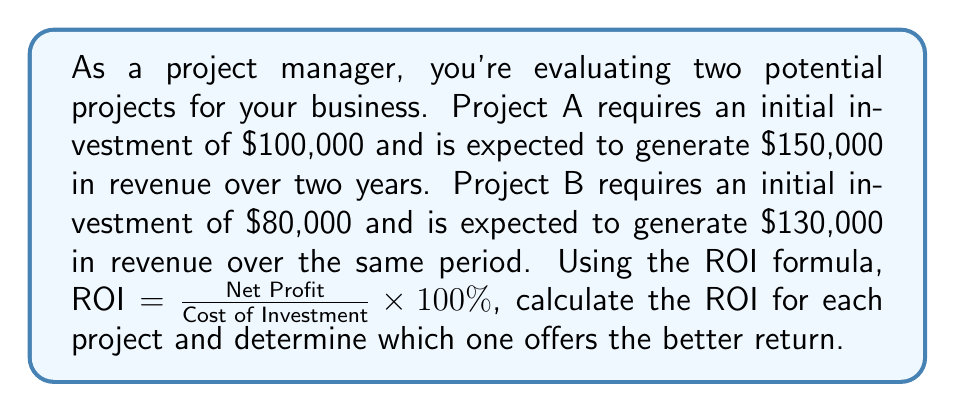Teach me how to tackle this problem. Let's calculate the ROI for each project:

1. Project A:
   - Initial Investment: $100,000
   - Revenue: $150,000
   - Net Profit = Revenue - Initial Investment
   $$Net Profit_A = 150,000 - 100,000 = 50,000$$
   
   ROI for Project A:
   $$ROI_A = \frac{50,000}{100,000} \times 100\% = 50\%$$

2. Project B:
   - Initial Investment: $80,000
   - Revenue: $130,000
   - Net Profit = Revenue - Initial Investment
   $$Net Profit_B = 130,000 - 80,000 = 50,000$$
   
   ROI for Project B:
   $$ROI_B = \frac{50,000}{80,000} \times 100\% = 62.5\%$$

Comparing the two ROIs:
Project A: 50%
Project B: 62.5%

Project B offers a higher ROI, making it the better investment choice based on this metric.
Answer: Project B with ROI of 62.5% 